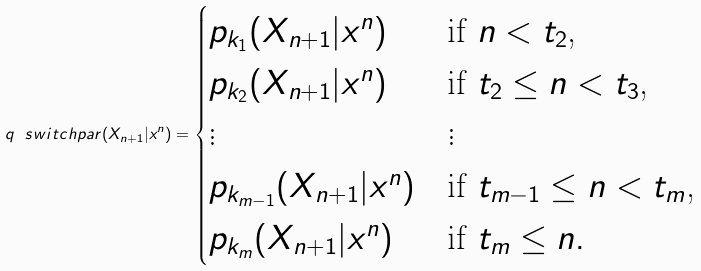Convert formula to latex. <formula><loc_0><loc_0><loc_500><loc_500>q _ { \ } s w i t c h p a r ( X _ { n + 1 } | x ^ { n } ) = \begin{cases} p _ { k _ { 1 } } ( X _ { n + 1 } | x ^ { n } ) & \text {if $n < t_{2}$,} \\ p _ { k _ { 2 } } ( X _ { n + 1 } | x ^ { n } ) & \text {if $t_{2} \leq n < t_{3}$,} \\ \vdots & \vdots \\ p _ { k _ { m - 1 } } ( X _ { n + 1 } | x ^ { n } ) & \text {if $t_{m-1} \leq n < t_{m}$,} \\ p _ { k _ { m } } ( X _ { n + 1 } | x ^ { n } ) & \text {if $t_{m} \leq n$} . \end{cases}</formula> 